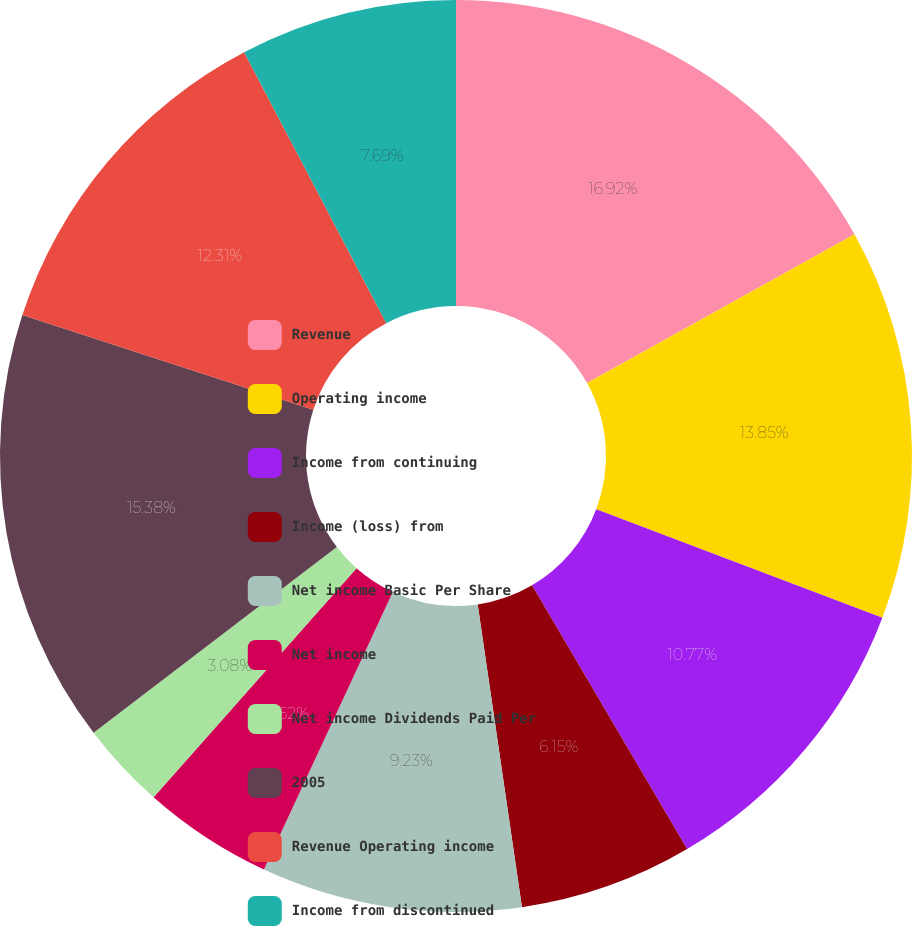Convert chart to OTSL. <chart><loc_0><loc_0><loc_500><loc_500><pie_chart><fcel>Revenue<fcel>Operating income<fcel>Income from continuing<fcel>Income (loss) from<fcel>Net income Basic Per Share<fcel>Net income<fcel>Net income Dividends Paid Per<fcel>2005<fcel>Revenue Operating income<fcel>Income from discontinued<nl><fcel>16.92%<fcel>13.85%<fcel>10.77%<fcel>6.15%<fcel>9.23%<fcel>4.62%<fcel>3.08%<fcel>15.38%<fcel>12.31%<fcel>7.69%<nl></chart> 